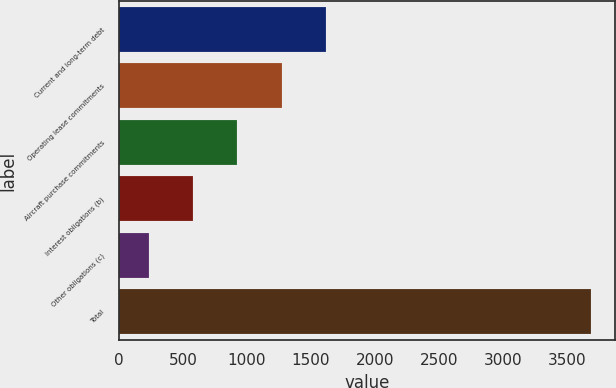<chart> <loc_0><loc_0><loc_500><loc_500><bar_chart><fcel>Current and long-term debt<fcel>Operating lease commitments<fcel>Aircraft purchase commitments<fcel>Interest obligations (b)<fcel>Other obligations (c)<fcel>Total<nl><fcel>1617.96<fcel>1272.47<fcel>926.98<fcel>581.49<fcel>236<fcel>3690.9<nl></chart> 